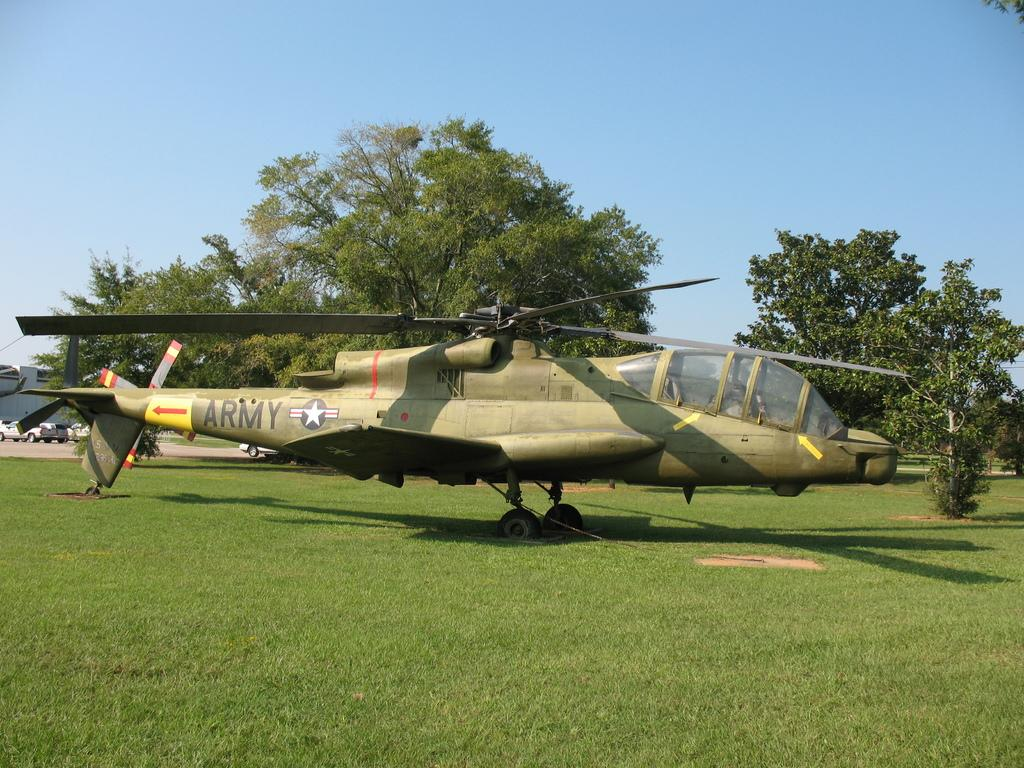<image>
Share a concise interpretation of the image provided. A green helicopter with the word ARMY written on the tail sits in the grass. 